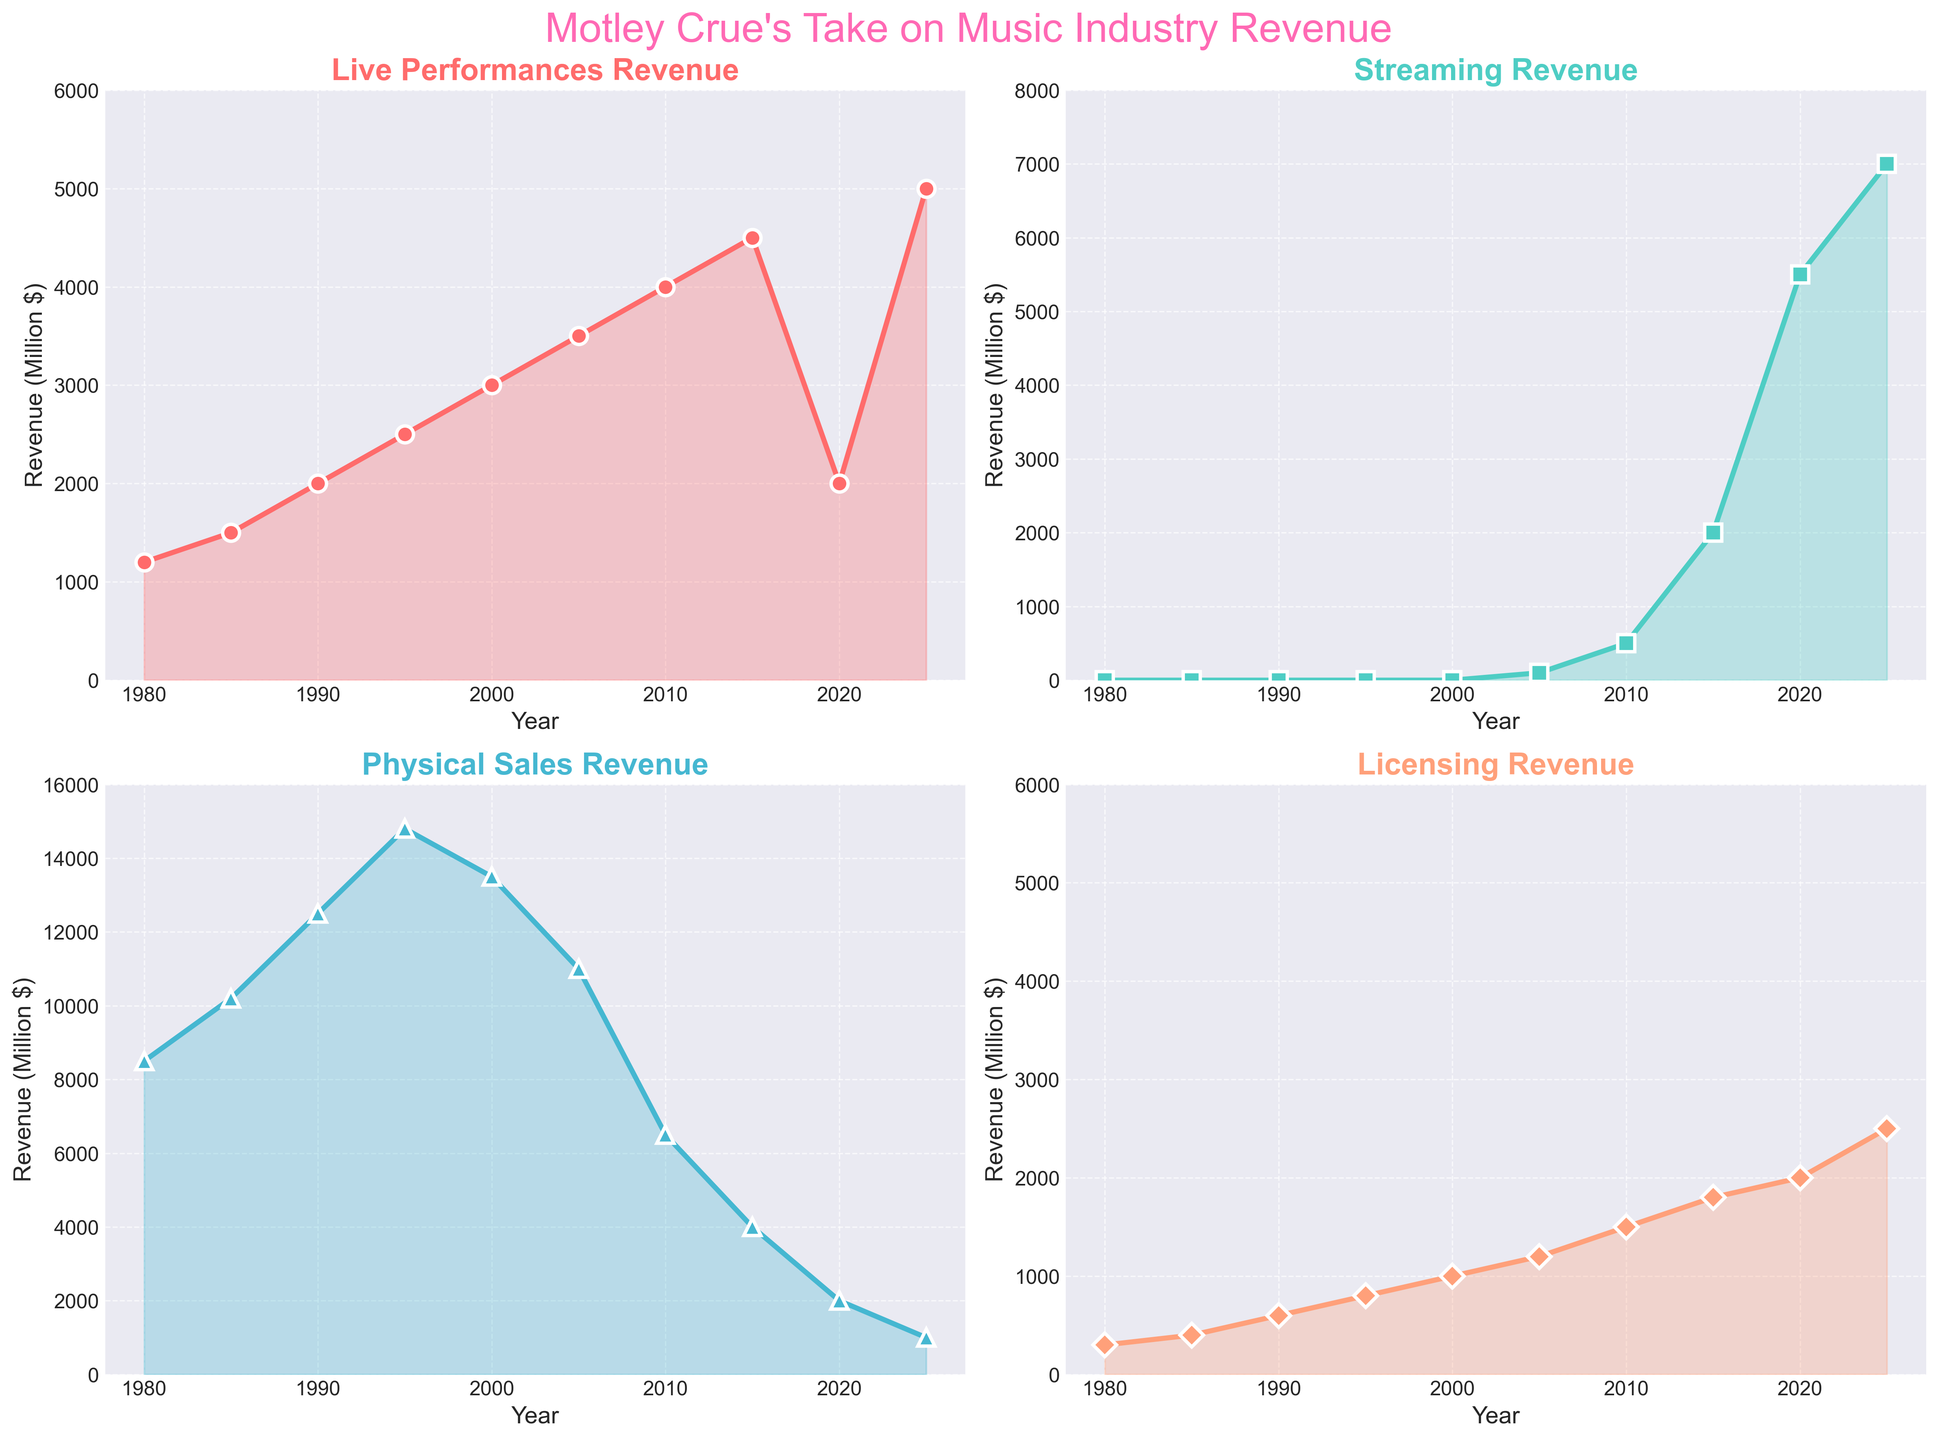Was the revenue from live performances higher in 2005 or 2020? To find the answer, we look at the live performances subplot and compare the y-values (revenue) for the years 2005 and 2020. In 2005, the revenue is 3500 million dollars, whereas in 2020, it is 2000 million dollars.
Answer: 2005 What is the trend in physical sales from 1995 to 2015? To determine the trend, we look at the physical sales subplot and observe the line from 1995 to 2015. The line decreases from 14800 million dollars in 1995 to 4000 million dollars in 2015.
Answer: Decreasing How does the streaming revenue in 2025 compare to physical sales revenue in the same year? To compare them, we look at their respective subplots for the year 2025. Streaming revenue is 7000 million dollars, while physical sales revenue is 1000 million dollars in 2025.
Answer: Higher What's the average live performance revenue from 1980 to 2000? To find the average, we sum the revenues for the years 1980, 1985, 1990, 1995, and 2000, which are 1200, 1500, 2000, 2500, and 3000 million dollars respectively. Sum = 10200 million dollars. The average is 10200 / 5 = 2040 million dollars.
Answer: 2040 Which category has the highest revenue in 2010? Examining the subplots for the year 2010, live performances have a revenue of 4000 million dollars, streaming 500 million dollars, physical sales 6500 million dollars, and licensing 1500 million dollars. Physical sales have the highest revenue in 2010.
Answer: Physical sales How did the licensing revenue change between 1980 and 2025? To determine the change, observe the licensing subplot. In 1980, the revenue is 300 million dollars; in 2025, it is 2500 million dollars. The increase is 2500 - 300 = 2200 million dollars.
Answer: Increased by 2200 million dollars What year saw the largest increase in streaming revenue? To find the year with the largest increase, look at the differences year-over-year in the streaming subplot. The largest difference occurs between 2015 (2000 million dollars) and 2020 (5500 million dollars), an increase of 3500 million dollars.
Answer: Between 2015 and 2020 Which category consistently shows a decrease in revenue over multiple time points? By observing all four subplots, the physical sales category shows a consistent decline from 2000 to 2025, from 13500 million dollars to 1000 million dollars.
Answer: Physical sales What is the combined revenue of all categories in 1985? To find the combined revenue, sum up the values of all four categories: live performances (1500), streaming (0), physical sales (10200), and licensing (400). Combined revenue is 1500 + 0 + 10200 + 400 = 12100 million dollars.
Answer: 12100 